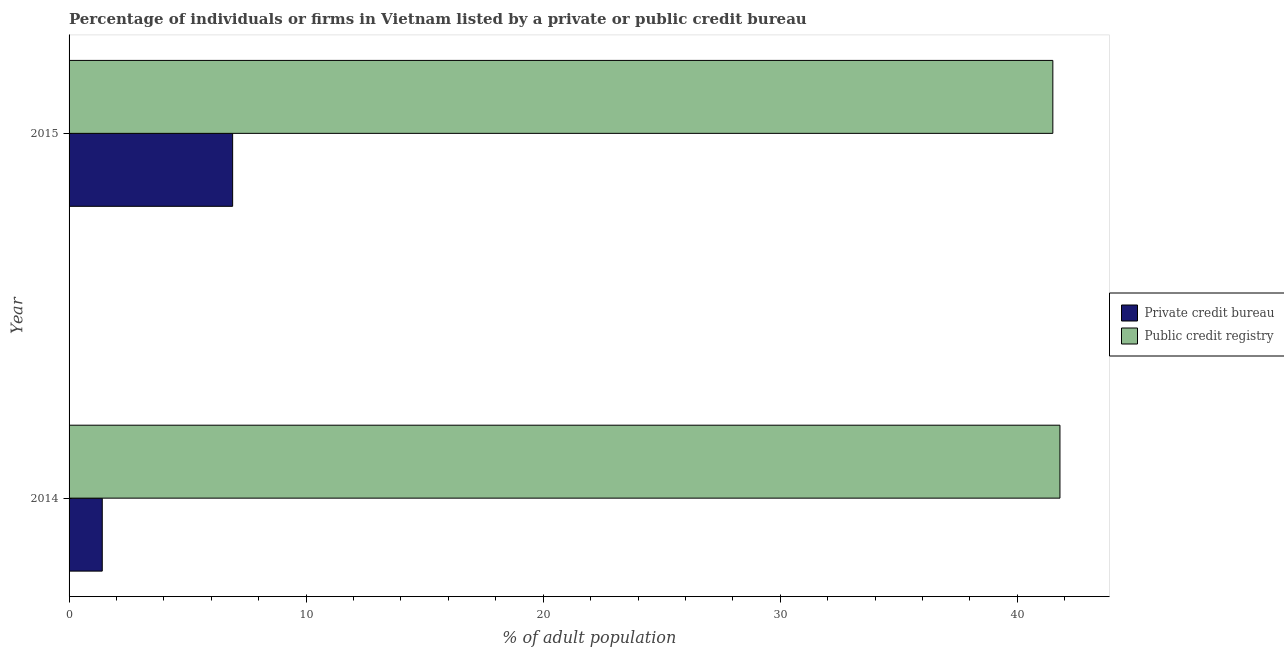How many different coloured bars are there?
Keep it short and to the point. 2. How many groups of bars are there?
Your answer should be very brief. 2. How many bars are there on the 2nd tick from the top?
Your answer should be very brief. 2. What is the label of the 1st group of bars from the top?
Your answer should be very brief. 2015. What is the percentage of firms listed by private credit bureau in 2014?
Your response must be concise. 1.4. Across all years, what is the minimum percentage of firms listed by private credit bureau?
Offer a very short reply. 1.4. In which year was the percentage of firms listed by private credit bureau maximum?
Provide a short and direct response. 2015. In which year was the percentage of firms listed by public credit bureau minimum?
Provide a short and direct response. 2015. What is the difference between the percentage of firms listed by private credit bureau in 2015 and the percentage of firms listed by public credit bureau in 2014?
Provide a short and direct response. -34.9. What is the average percentage of firms listed by public credit bureau per year?
Keep it short and to the point. 41.65. In the year 2014, what is the difference between the percentage of firms listed by public credit bureau and percentage of firms listed by private credit bureau?
Offer a very short reply. 40.4. What is the ratio of the percentage of firms listed by private credit bureau in 2014 to that in 2015?
Your answer should be very brief. 0.2. In how many years, is the percentage of firms listed by private credit bureau greater than the average percentage of firms listed by private credit bureau taken over all years?
Your response must be concise. 1. What does the 2nd bar from the top in 2014 represents?
Offer a very short reply. Private credit bureau. What does the 2nd bar from the bottom in 2015 represents?
Make the answer very short. Public credit registry. How many bars are there?
Your answer should be very brief. 4. Are all the bars in the graph horizontal?
Offer a very short reply. Yes. Does the graph contain any zero values?
Offer a very short reply. No. Where does the legend appear in the graph?
Offer a very short reply. Center right. How are the legend labels stacked?
Give a very brief answer. Vertical. What is the title of the graph?
Your answer should be very brief. Percentage of individuals or firms in Vietnam listed by a private or public credit bureau. What is the label or title of the X-axis?
Your answer should be very brief. % of adult population. What is the % of adult population in Public credit registry in 2014?
Offer a terse response. 41.8. What is the % of adult population of Public credit registry in 2015?
Ensure brevity in your answer.  41.5. Across all years, what is the maximum % of adult population in Public credit registry?
Offer a terse response. 41.8. Across all years, what is the minimum % of adult population in Public credit registry?
Offer a terse response. 41.5. What is the total % of adult population in Private credit bureau in the graph?
Keep it short and to the point. 8.3. What is the total % of adult population of Public credit registry in the graph?
Ensure brevity in your answer.  83.3. What is the difference between the % of adult population in Private credit bureau in 2014 and that in 2015?
Provide a short and direct response. -5.5. What is the difference between the % of adult population in Public credit registry in 2014 and that in 2015?
Your response must be concise. 0.3. What is the difference between the % of adult population in Private credit bureau in 2014 and the % of adult population in Public credit registry in 2015?
Your response must be concise. -40.1. What is the average % of adult population of Private credit bureau per year?
Offer a very short reply. 4.15. What is the average % of adult population in Public credit registry per year?
Make the answer very short. 41.65. In the year 2014, what is the difference between the % of adult population of Private credit bureau and % of adult population of Public credit registry?
Offer a terse response. -40.4. In the year 2015, what is the difference between the % of adult population in Private credit bureau and % of adult population in Public credit registry?
Give a very brief answer. -34.6. What is the ratio of the % of adult population in Private credit bureau in 2014 to that in 2015?
Offer a very short reply. 0.2. What is the ratio of the % of adult population in Public credit registry in 2014 to that in 2015?
Your answer should be very brief. 1.01. What is the difference between the highest and the lowest % of adult population of Private credit bureau?
Your answer should be very brief. 5.5. 